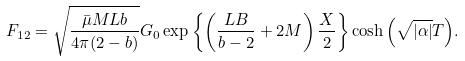Convert formula to latex. <formula><loc_0><loc_0><loc_500><loc_500>F _ { 1 2 } = \sqrt { \frac { \bar { \mu } M L b } { 4 \pi ( 2 - b ) } } G _ { 0 } \exp { \left \{ \left ( \frac { L B } { b - 2 } + 2 M \right ) \frac { X } { 2 } \right \} } \cosh { \left ( \sqrt { | \alpha | } T \right ) } .</formula> 